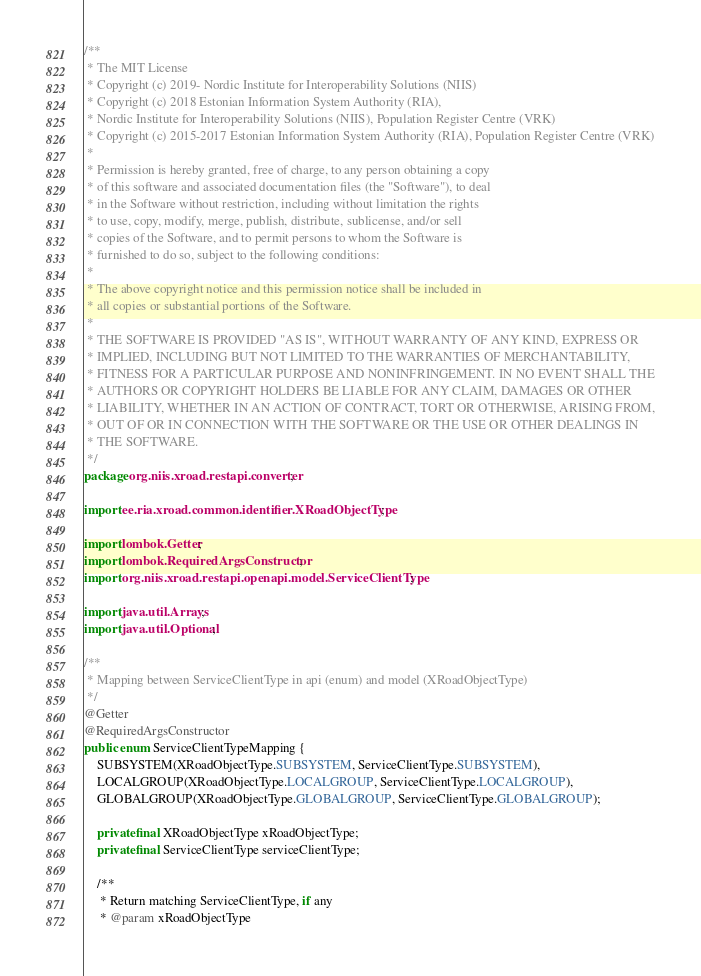<code> <loc_0><loc_0><loc_500><loc_500><_Java_>/**
 * The MIT License
 * Copyright (c) 2019- Nordic Institute for Interoperability Solutions (NIIS)
 * Copyright (c) 2018 Estonian Information System Authority (RIA),
 * Nordic Institute for Interoperability Solutions (NIIS), Population Register Centre (VRK)
 * Copyright (c) 2015-2017 Estonian Information System Authority (RIA), Population Register Centre (VRK)
 *
 * Permission is hereby granted, free of charge, to any person obtaining a copy
 * of this software and associated documentation files (the "Software"), to deal
 * in the Software without restriction, including without limitation the rights
 * to use, copy, modify, merge, publish, distribute, sublicense, and/or sell
 * copies of the Software, and to permit persons to whom the Software is
 * furnished to do so, subject to the following conditions:
 *
 * The above copyright notice and this permission notice shall be included in
 * all copies or substantial portions of the Software.
 *
 * THE SOFTWARE IS PROVIDED "AS IS", WITHOUT WARRANTY OF ANY KIND, EXPRESS OR
 * IMPLIED, INCLUDING BUT NOT LIMITED TO THE WARRANTIES OF MERCHANTABILITY,
 * FITNESS FOR A PARTICULAR PURPOSE AND NONINFRINGEMENT. IN NO EVENT SHALL THE
 * AUTHORS OR COPYRIGHT HOLDERS BE LIABLE FOR ANY CLAIM, DAMAGES OR OTHER
 * LIABILITY, WHETHER IN AN ACTION OF CONTRACT, TORT OR OTHERWISE, ARISING FROM,
 * OUT OF OR IN CONNECTION WITH THE SOFTWARE OR THE USE OR OTHER DEALINGS IN
 * THE SOFTWARE.
 */
package org.niis.xroad.restapi.converter;

import ee.ria.xroad.common.identifier.XRoadObjectType;

import lombok.Getter;
import lombok.RequiredArgsConstructor;
import org.niis.xroad.restapi.openapi.model.ServiceClientType;

import java.util.Arrays;
import java.util.Optional;

/**
 * Mapping between ServiceClientType in api (enum) and model (XRoadObjectType)
 */
@Getter
@RequiredArgsConstructor
public enum ServiceClientTypeMapping {
    SUBSYSTEM(XRoadObjectType.SUBSYSTEM, ServiceClientType.SUBSYSTEM),
    LOCALGROUP(XRoadObjectType.LOCALGROUP, ServiceClientType.LOCALGROUP),
    GLOBALGROUP(XRoadObjectType.GLOBALGROUP, ServiceClientType.GLOBALGROUP);

    private final XRoadObjectType xRoadObjectType;
    private final ServiceClientType serviceClientType;

    /**
     * Return matching ServiceClientType, if any
     * @param xRoadObjectType</code> 